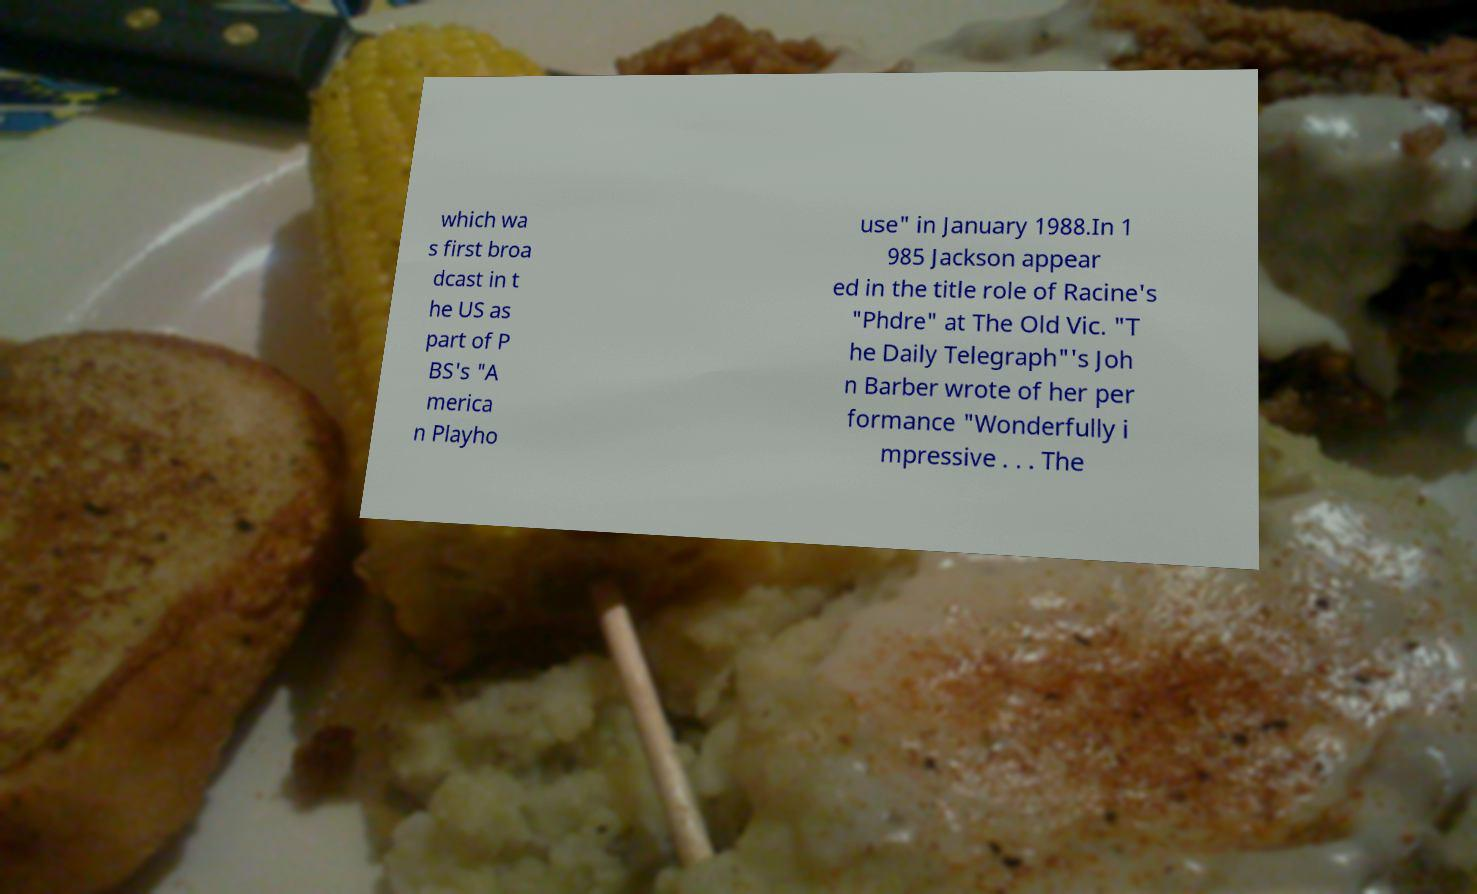Please read and relay the text visible in this image. What does it say? which wa s first broa dcast in t he US as part of P BS's "A merica n Playho use" in January 1988.In 1 985 Jackson appear ed in the title role of Racine's "Phdre" at The Old Vic. "T he Daily Telegraph"'s Joh n Barber wrote of her per formance "Wonderfully i mpressive . . . The 